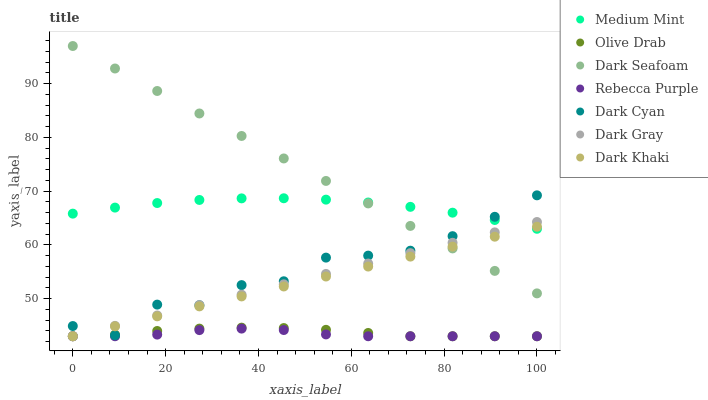Does Rebecca Purple have the minimum area under the curve?
Answer yes or no. Yes. Does Dark Seafoam have the maximum area under the curve?
Answer yes or no. Yes. Does Dark Khaki have the minimum area under the curve?
Answer yes or no. No. Does Dark Khaki have the maximum area under the curve?
Answer yes or no. No. Is Dark Khaki the smoothest?
Answer yes or no. Yes. Is Dark Cyan the roughest?
Answer yes or no. Yes. Is Dark Gray the smoothest?
Answer yes or no. No. Is Dark Gray the roughest?
Answer yes or no. No. Does Dark Khaki have the lowest value?
Answer yes or no. Yes. Does Dark Seafoam have the lowest value?
Answer yes or no. No. Does Dark Seafoam have the highest value?
Answer yes or no. Yes. Does Dark Khaki have the highest value?
Answer yes or no. No. Is Olive Drab less than Medium Mint?
Answer yes or no. Yes. Is Medium Mint greater than Olive Drab?
Answer yes or no. Yes. Does Rebecca Purple intersect Dark Khaki?
Answer yes or no. Yes. Is Rebecca Purple less than Dark Khaki?
Answer yes or no. No. Is Rebecca Purple greater than Dark Khaki?
Answer yes or no. No. Does Olive Drab intersect Medium Mint?
Answer yes or no. No. 